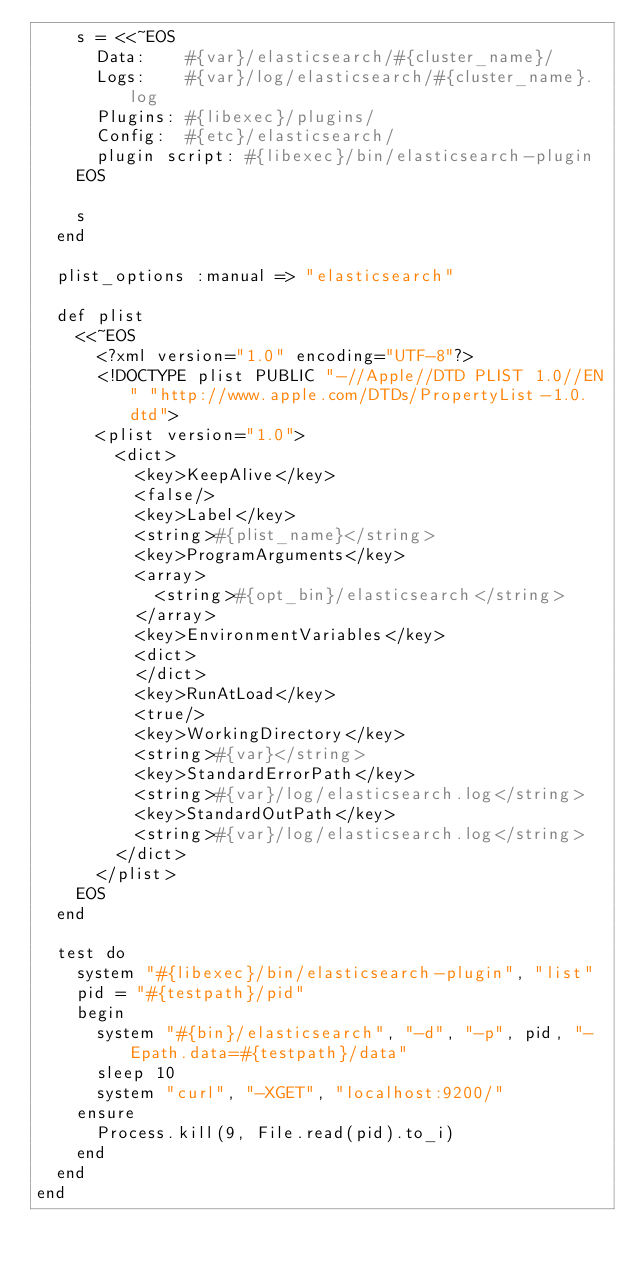Convert code to text. <code><loc_0><loc_0><loc_500><loc_500><_Ruby_>    s = <<~EOS
      Data:    #{var}/elasticsearch/#{cluster_name}/
      Logs:    #{var}/log/elasticsearch/#{cluster_name}.log
      Plugins: #{libexec}/plugins/
      Config:  #{etc}/elasticsearch/
      plugin script: #{libexec}/bin/elasticsearch-plugin
    EOS

    s
  end

  plist_options :manual => "elasticsearch"

  def plist
    <<~EOS
      <?xml version="1.0" encoding="UTF-8"?>
      <!DOCTYPE plist PUBLIC "-//Apple//DTD PLIST 1.0//EN" "http://www.apple.com/DTDs/PropertyList-1.0.dtd">
      <plist version="1.0">
        <dict>
          <key>KeepAlive</key>
          <false/>
          <key>Label</key>
          <string>#{plist_name}</string>
          <key>ProgramArguments</key>
          <array>
            <string>#{opt_bin}/elasticsearch</string>
          </array>
          <key>EnvironmentVariables</key>
          <dict>
          </dict>
          <key>RunAtLoad</key>
          <true/>
          <key>WorkingDirectory</key>
          <string>#{var}</string>
          <key>StandardErrorPath</key>
          <string>#{var}/log/elasticsearch.log</string>
          <key>StandardOutPath</key>
          <string>#{var}/log/elasticsearch.log</string>
        </dict>
      </plist>
    EOS
  end

  test do
    system "#{libexec}/bin/elasticsearch-plugin", "list"
    pid = "#{testpath}/pid"
    begin
      system "#{bin}/elasticsearch", "-d", "-p", pid, "-Epath.data=#{testpath}/data"
      sleep 10
      system "curl", "-XGET", "localhost:9200/"
    ensure
      Process.kill(9, File.read(pid).to_i)
    end
  end
end
</code> 